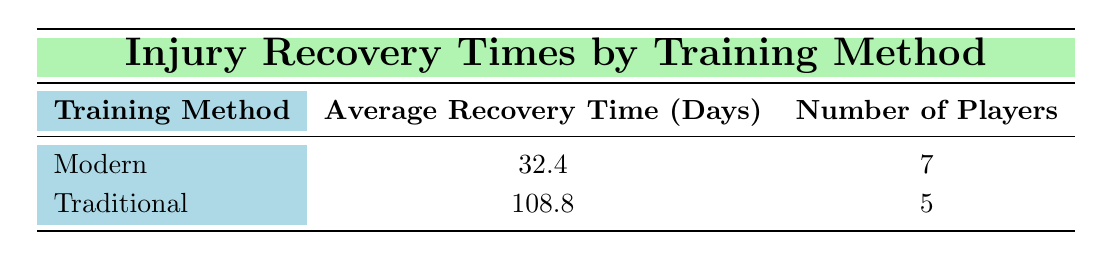What is the average recovery time for players using modern training methods? The table shows that the average recovery time for players using modern training methods is listed directly under the "Average Recovery Time (Days)" column for that training method, which is 32.4 days.
Answer: 32.4 days What is the average recovery time for players using traditional training methods? The average recovery time for players using traditional training methods is presented in the table as well, specifically for that training method, which is 108.8 days.
Answer: 108.8 days How many players were analyzed using traditional training methods? According to the table, the "Number of Players" column for the traditional training method indicates there were 5 players included in the analysis.
Answer: 5 players Is the average recovery time for traditional training methods greater than that for modern methods? The average recovery time for traditional training methods is 108.8 days, while for modern methods, it is 32.4 days. Comparatively, 108.8 is greater than 32.4, confirming the statement is true.
Answer: Yes What is the difference in average recovery times between modern and traditional training methods? To find the difference, subtract the average recovery time for modern methods (32.4 days) from that for traditional methods (108.8 days). The calculation is 108.8 - 32.4 = 76.4 days.
Answer: 76.4 days What percentage of the total players analyzed used modern training methods? The total number of players analyzed is 12 (7 modern + 5 traditional). The number of players using modern training methods is 7, so the percentage is calculated as (7/12) * 100 = 58.33%.
Answer: 58.33% Is it true that more players experienced longer recovery times with traditional training methods compared to modern methods? By examining the "Number of Players" column, it shows there are 5 players in the traditional method group and the average recovery time is significantly higher (108.8 days) compared to the 7 players in the modern group with an average of 32.4 days. Thus, it can be concluded that, on average, players with traditional methods have longer recovery times, confirming that the statement is true.
Answer: Yes How many players had recovery times shorter than 30 days? Reviewing the data, players with recovery times below 30 days are specifically from the modern method group: Harry Kane (28), Kevin De Bruyne (21), Trent Alexander-Arnold (18), and Kylian Mbappe (19). A count of these players shows there are 4 such instances.
Answer: 4 players Which training method resulted in a higher average recovery time, traditional or modern? The average recovery time for traditional training methods is 108.8 days, and for modern methods, it is 32.4 days. Since 108.8 is greater than 32.4, it confirms that traditional training results in a higher average recovery time.
Answer: Traditional training methods 